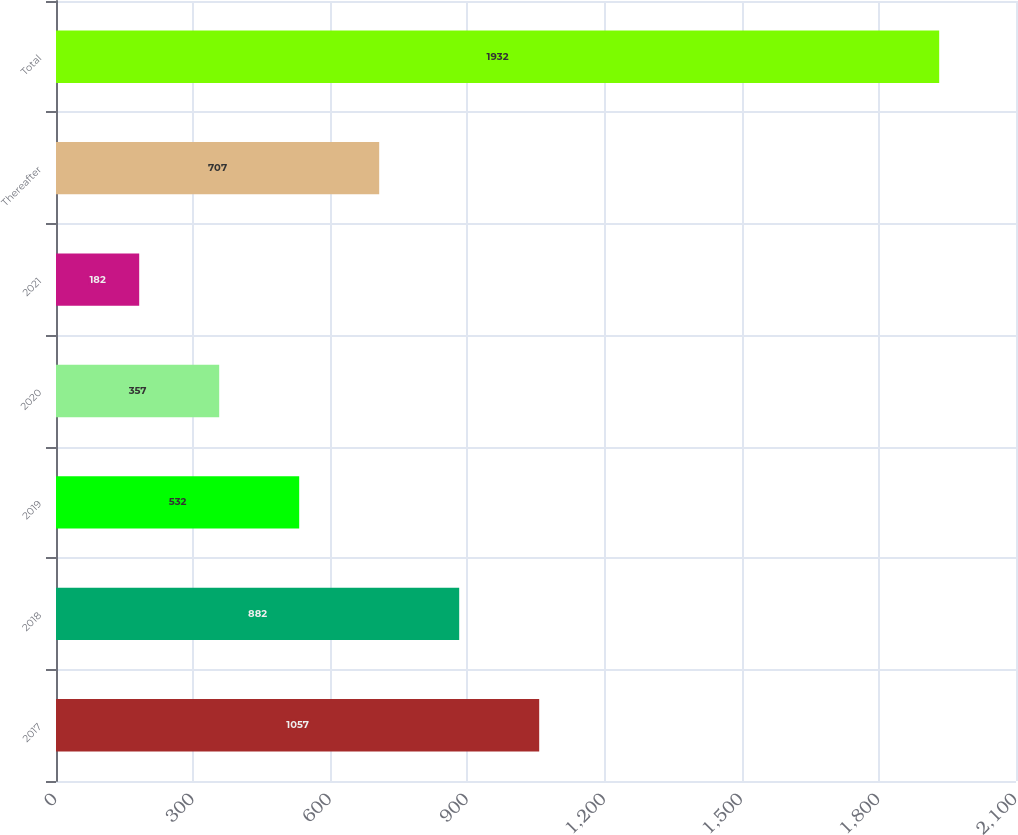<chart> <loc_0><loc_0><loc_500><loc_500><bar_chart><fcel>2017<fcel>2018<fcel>2019<fcel>2020<fcel>2021<fcel>Thereafter<fcel>Total<nl><fcel>1057<fcel>882<fcel>532<fcel>357<fcel>182<fcel>707<fcel>1932<nl></chart> 